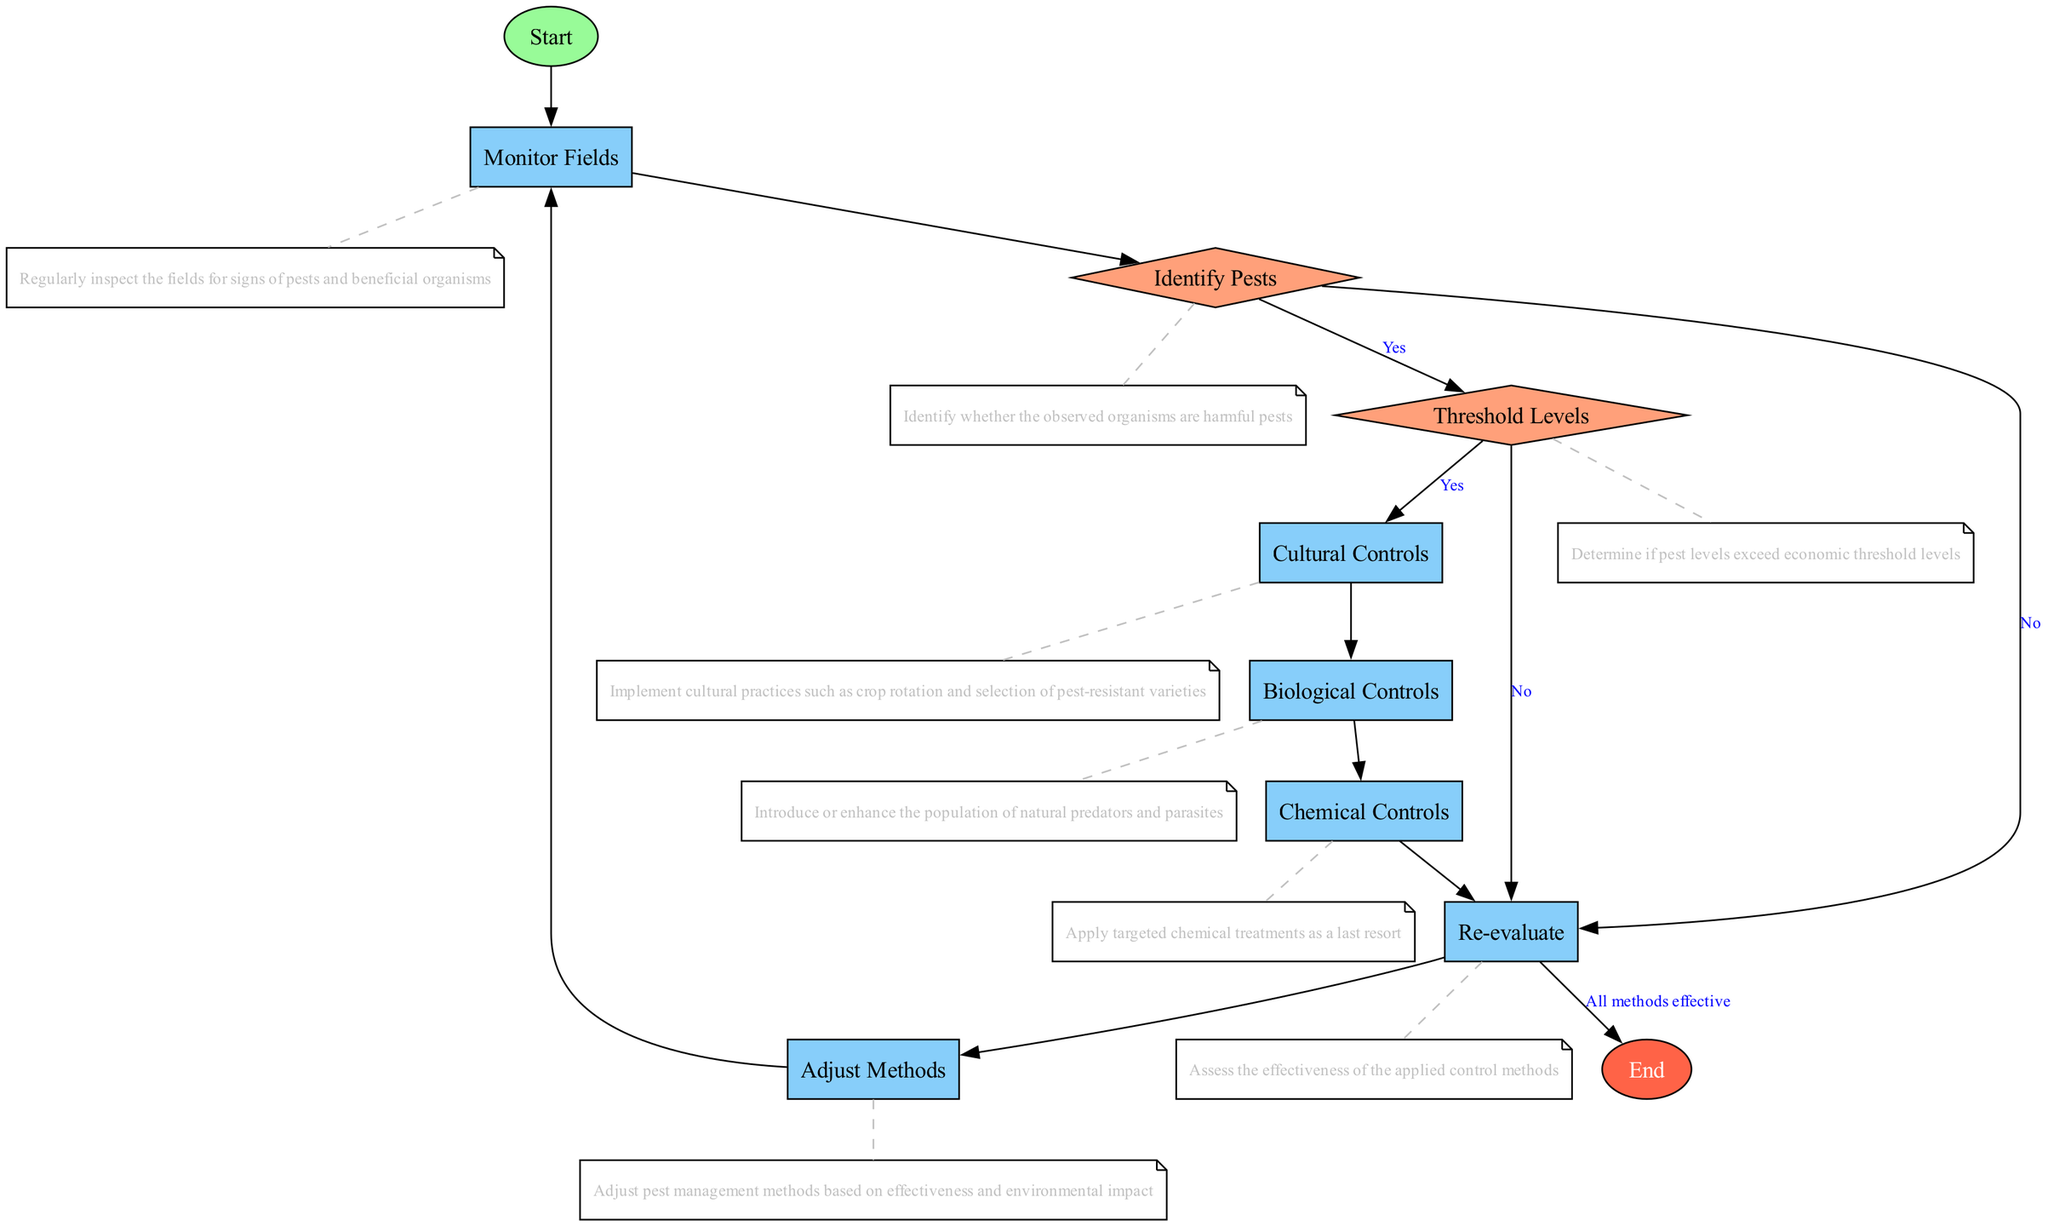What is the first node in the flowchart? The first node is labeled "Start," which initiates the flow of the process. This can be identified as the node leading directly from the beginning of the diagram without any preceding connections.
Answer: Start How many types of nodes are present in the diagram? There are four distinct types of nodes: start, process, decision, and end. Each type serves a different purpose in the flowchart, contributing to the overall structure and function.
Answer: Four What happens if pests are not identified as harmful? If pests are identified as not harmful, the flowchart proceeds to the "Re-evaluate" node, indicating the need to assess the current situation rather than taking further pest management actions.
Answer: Re-evaluate How many connections lead from the "Threshold Levels" node? There are two connections leading from the "Threshold Levels" node; one leads to "Cultural Controls" and another to "Re-evaluate," depending on whether the pest levels exceed economic thresholds.
Answer: Two What controls are implemented after confirming pests exceed threshold levels? After confirming that pest levels exceed threshold levels, the flowchart directs to "Cultural Controls," indicating that cultural practices should be implemented to manage pests effectively.
Answer: Cultural Controls What is the relationship between "Re-evaluate" and "Adjust Methods"? The "Re-evaluate" node directly connects to the "Adjust Methods" node, indicating that the effectiveness of pest management methods needs to be assessed before making adjustments based on that evaluation.
Answer: Direct connection What is the final outcome if all methods are effective? If all methods are effective, the flowchart concludes at the "End" node, signifying the successful completion of the Integrated Pest Management strategy without further actions needed.
Answer: End What follows after "Chemical Controls" in the sequence? After the "Chemical Controls," the flowchart proceeds to the "Re-evaluate" node, suggesting that the effectiveness of the chemical solutions applied must be assessed before moving forward.
Answer: Re-evaluate What node follows "Adjust Methods"? The node that follows "Adjust Methods" is "Monitor Fields," indicating a return to the regular monitoring of the fields as part of the pest management cycle.
Answer: Monitor Fields 